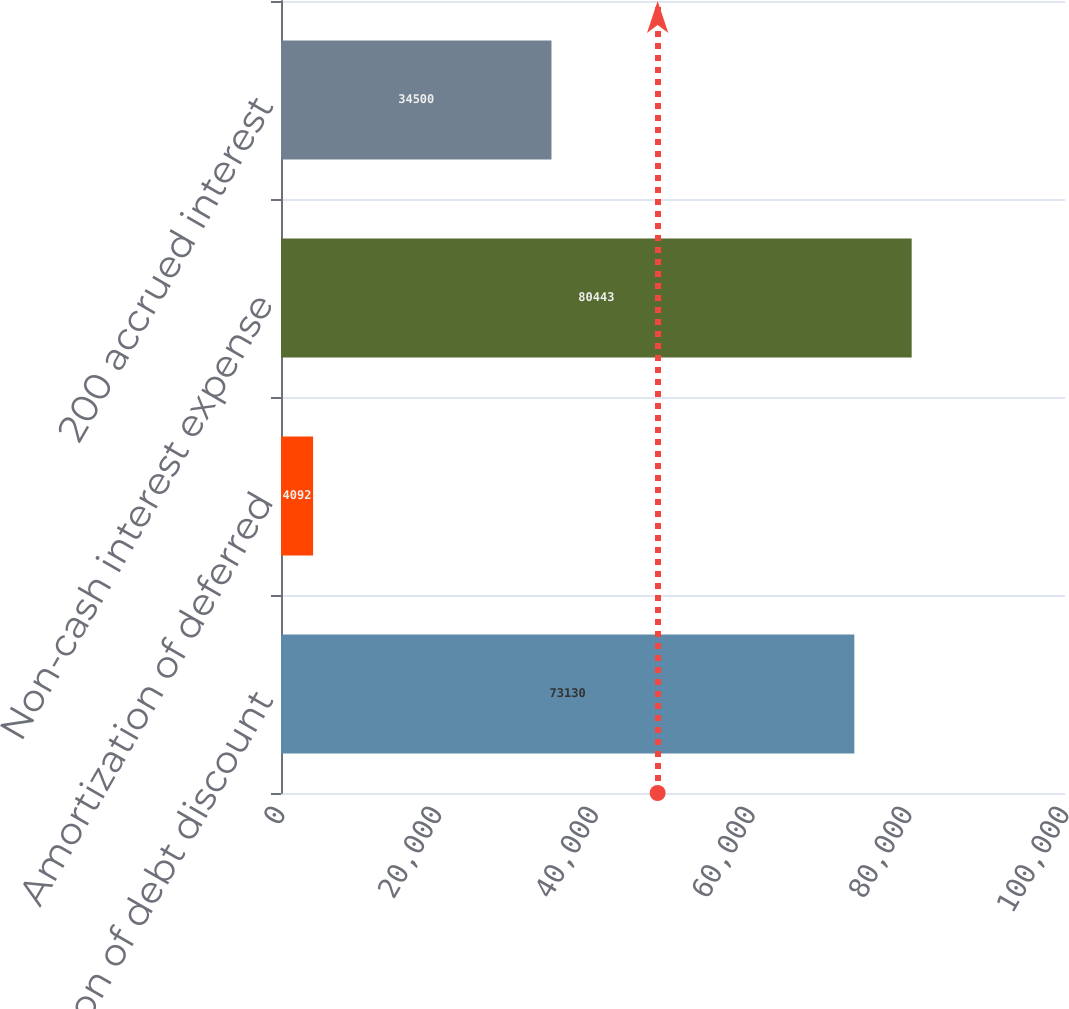Convert chart to OTSL. <chart><loc_0><loc_0><loc_500><loc_500><bar_chart><fcel>Amortization of debt discount<fcel>Amortization of deferred<fcel>Non-cash interest expense<fcel>200 accrued interest<nl><fcel>73130<fcel>4092<fcel>80443<fcel>34500<nl></chart> 